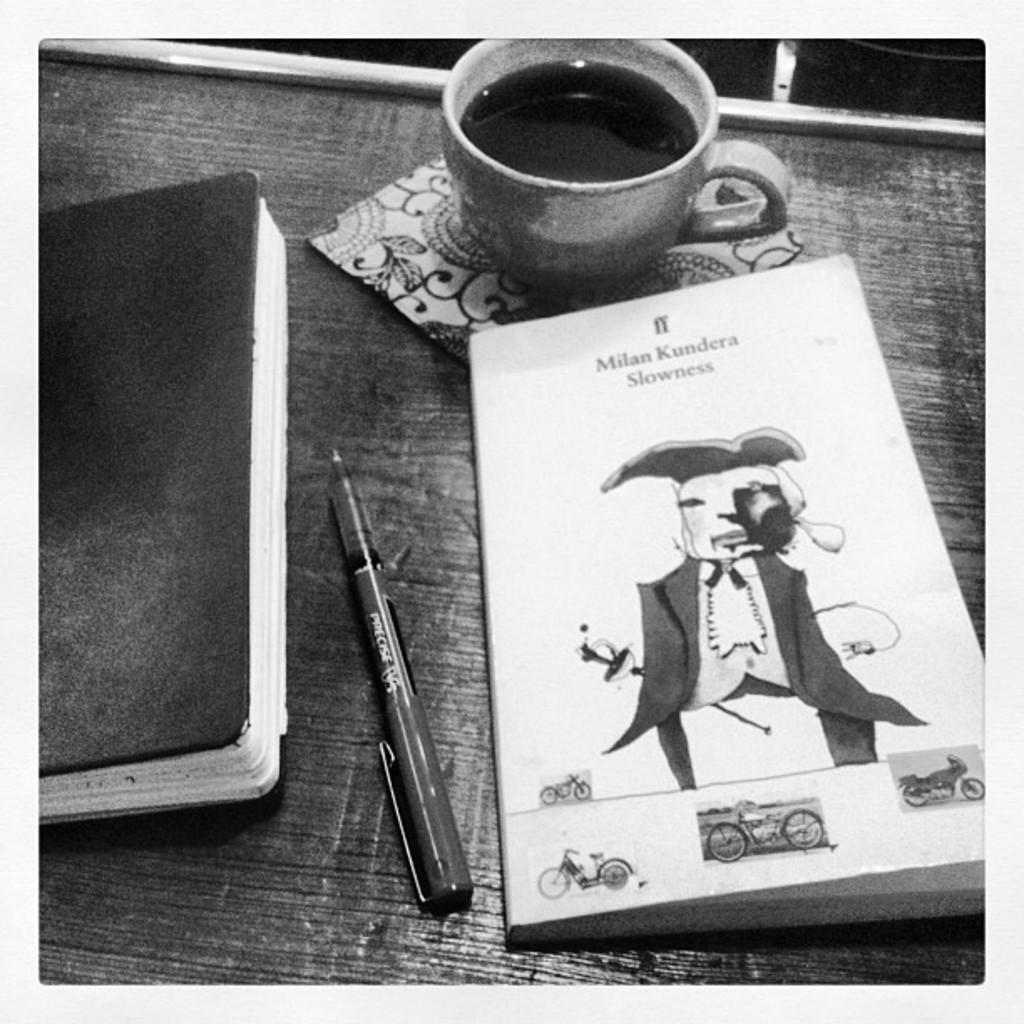What is the color scheme of the image? The image is black and white. What writing instrument is visible in the image? There is a pen in the image. What type of stationery item is present in the image? There is a diary and a notebook in the image. What is depicted on the notebook? The notebook has pictures of motorbikes. What is the drink in the cup? The specific type of drink in the cup cannot be determined from the image. What type of table is present in the image? The wooden table is present in the image. How many bushes are visible in the image? There are no bushes present in the image. What type of learning material is depicted in the image? There is no learning material depicted in the image; it features a diary, a notebook with motorbike pictures, and a pen. 